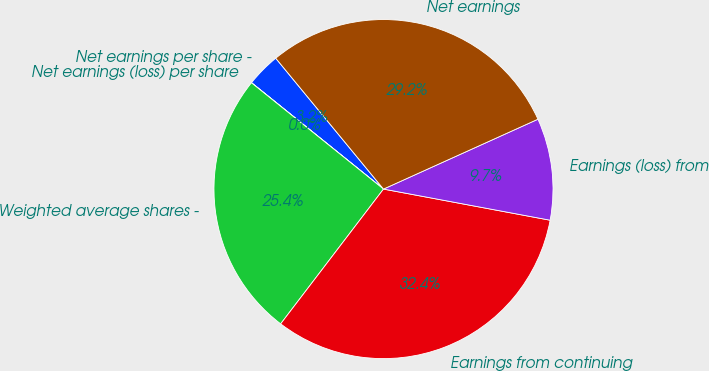Convert chart. <chart><loc_0><loc_0><loc_500><loc_500><pie_chart><fcel>Net earnings per share -<fcel>Net earnings (loss) per share<fcel>Weighted average shares -<fcel>Earnings from continuing<fcel>Earnings (loss) from<fcel>Net earnings<nl><fcel>3.24%<fcel>0.01%<fcel>25.41%<fcel>32.43%<fcel>9.7%<fcel>29.2%<nl></chart> 